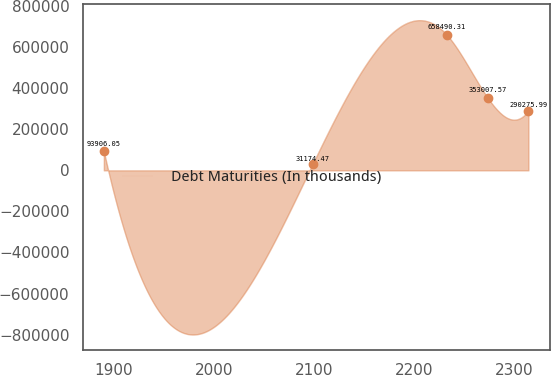<chart> <loc_0><loc_0><loc_500><loc_500><line_chart><ecel><fcel>Debt Maturities (In thousands)<nl><fcel>1890.06<fcel>93906.1<nl><fcel>2098.66<fcel>31174.5<nl><fcel>2232.87<fcel>658490<nl><fcel>2273.47<fcel>353008<nl><fcel>2314.07<fcel>290276<nl></chart> 